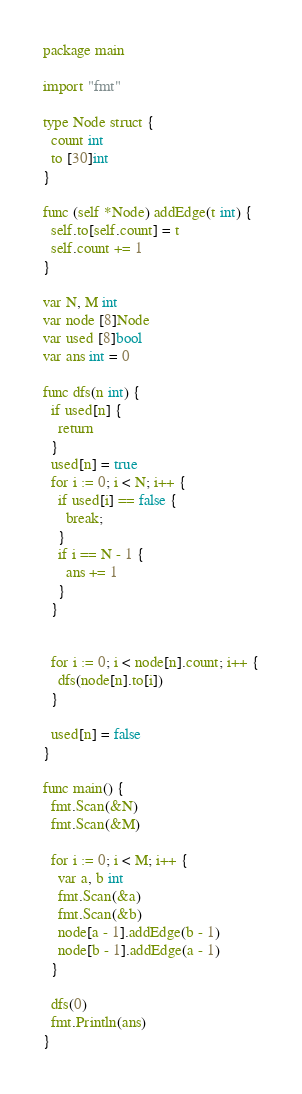Convert code to text. <code><loc_0><loc_0><loc_500><loc_500><_Go_>package main

import "fmt"

type Node struct {
  count int
  to [30]int
}

func (self *Node) addEdge(t int) {
  self.to[self.count] = t
  self.count += 1
}

var N, M int
var node [8]Node
var used [8]bool
var ans int = 0

func dfs(n int) {
  if used[n] {
    return
  }
  used[n] = true
  for i := 0; i < N; i++ {
    if used[i] == false {
      break;
    }
    if i == N - 1 {
      ans += 1
    }
  }


  for i := 0; i < node[n].count; i++ {
    dfs(node[n].to[i])
  }

  used[n] = false
}

func main() {
  fmt.Scan(&N)
  fmt.Scan(&M)

  for i := 0; i < M; i++ {
    var a, b int
    fmt.Scan(&a)
    fmt.Scan(&b)
    node[a - 1].addEdge(b - 1)
    node[b - 1].addEdge(a - 1)
  }

  dfs(0)
  fmt.Println(ans)
}</code> 